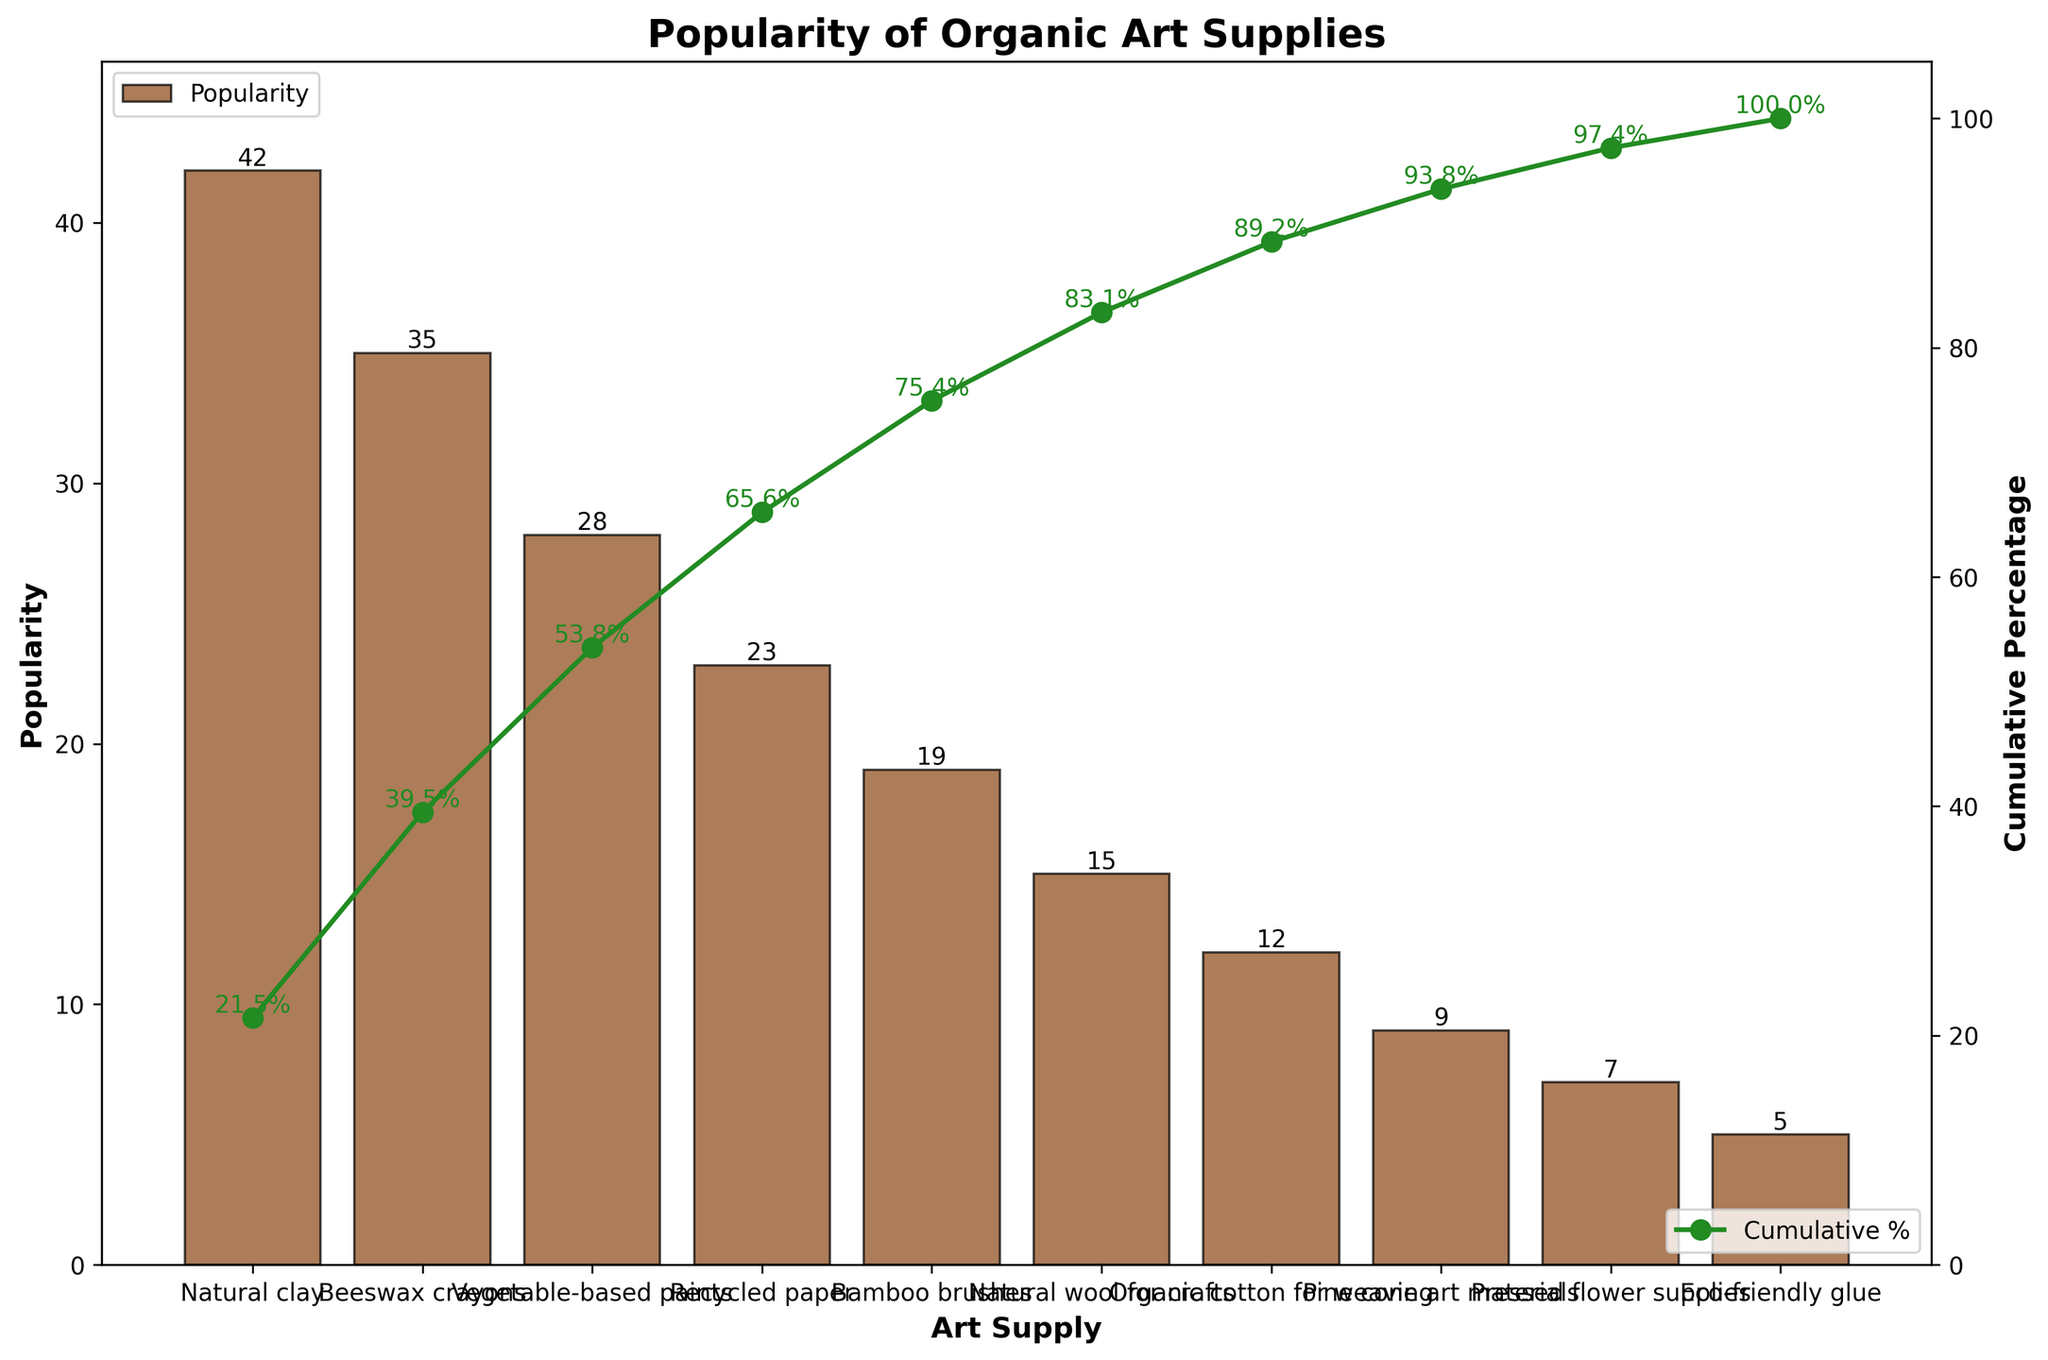What is the title of the chart? The title is located at the top of the chart, above the plot area. It is typically in a larger and bold font.
Answer: Popularity of Organic Art Supplies Which art supply has the highest popularity? The art supply with the highest popularity will be represented by the tallest bar in the chart.
Answer: Natural clay How many art supplies have a popularity greater than 20? Identify the bars whose height represents popularity values greater than 20 and count them.
Answer: Four Which art supply contributes to the cumulative percentage crossing 70%? Look at the curve representing cumulative percentage and identify the art supply corresponding to the point where the cumulative percentage first exceeds 70%.
Answer: Recycled paper What is the cumulative percentage for the third most popular art supply? Identify the third bar from the left and look at the corresponding point on the cumulative percentage line.
Answer: 66.4% What is the difference in popularity between bamboo brushes and natural wool for crafts? Subtract the popularity of natural wool for crafts from the popularity of bamboo brushes (19 - 15).
Answer: 4 Which two art supplies have a combined popularity of exactly 23? Identify pairs of art supplies whose popularity values add up to 23 by checking the heights of the bars.
Answer: Natural clay and pine cone art materials How many art supplies have a cumulative percentage less than 50%? Look at the cumulative percentage line and count the points that are below the 50% mark.
Answer: Three Which has a higher popularity, organic cotton for weaving or eco-friendly glue? Compare the heights of the bars representing organic cotton for weaving and eco-friendly glue.
Answer: Organic cotton for weaving What is the cumulative percentage right after the natural wool for crafts? Locate the bar for natural wool for crafts and check the value of the next cumulative percentage point.
Answer: 88.3% 